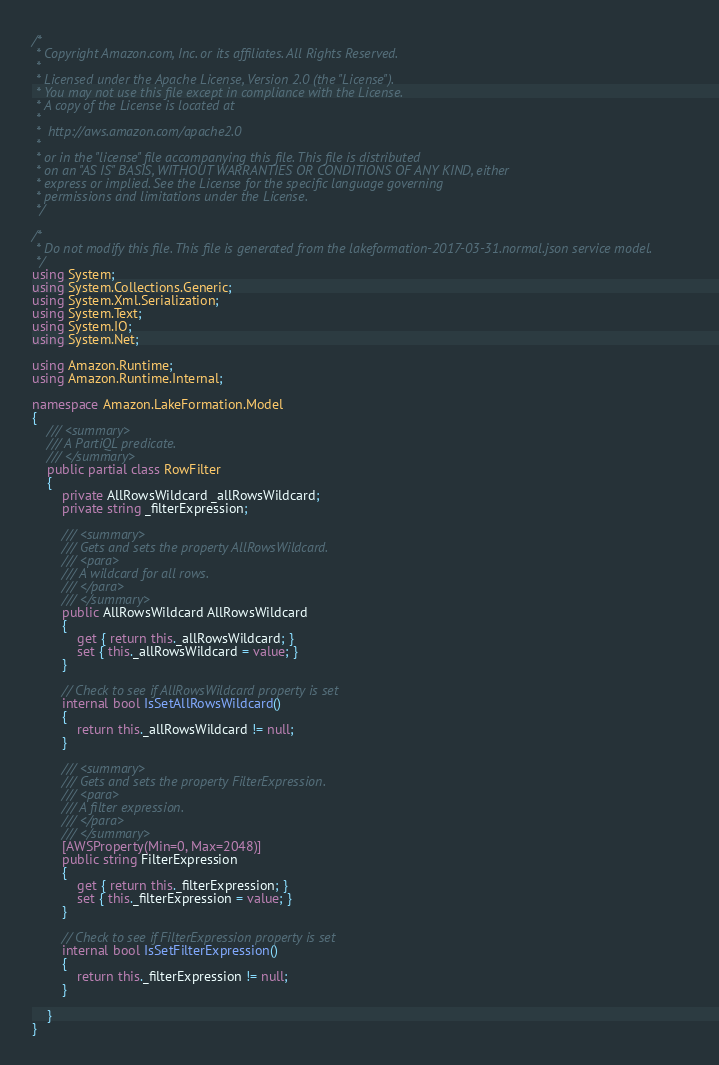<code> <loc_0><loc_0><loc_500><loc_500><_C#_>/*
 * Copyright Amazon.com, Inc. or its affiliates. All Rights Reserved.
 * 
 * Licensed under the Apache License, Version 2.0 (the "License").
 * You may not use this file except in compliance with the License.
 * A copy of the License is located at
 * 
 *  http://aws.amazon.com/apache2.0
 * 
 * or in the "license" file accompanying this file. This file is distributed
 * on an "AS IS" BASIS, WITHOUT WARRANTIES OR CONDITIONS OF ANY KIND, either
 * express or implied. See the License for the specific language governing
 * permissions and limitations under the License.
 */

/*
 * Do not modify this file. This file is generated from the lakeformation-2017-03-31.normal.json service model.
 */
using System;
using System.Collections.Generic;
using System.Xml.Serialization;
using System.Text;
using System.IO;
using System.Net;

using Amazon.Runtime;
using Amazon.Runtime.Internal;

namespace Amazon.LakeFormation.Model
{
    /// <summary>
    /// A PartiQL predicate.
    /// </summary>
    public partial class RowFilter
    {
        private AllRowsWildcard _allRowsWildcard;
        private string _filterExpression;

        /// <summary>
        /// Gets and sets the property AllRowsWildcard. 
        /// <para>
        /// A wildcard for all rows.
        /// </para>
        /// </summary>
        public AllRowsWildcard AllRowsWildcard
        {
            get { return this._allRowsWildcard; }
            set { this._allRowsWildcard = value; }
        }

        // Check to see if AllRowsWildcard property is set
        internal bool IsSetAllRowsWildcard()
        {
            return this._allRowsWildcard != null;
        }

        /// <summary>
        /// Gets and sets the property FilterExpression. 
        /// <para>
        /// A filter expression.
        /// </para>
        /// </summary>
        [AWSProperty(Min=0, Max=2048)]
        public string FilterExpression
        {
            get { return this._filterExpression; }
            set { this._filterExpression = value; }
        }

        // Check to see if FilterExpression property is set
        internal bool IsSetFilterExpression()
        {
            return this._filterExpression != null;
        }

    }
}</code> 